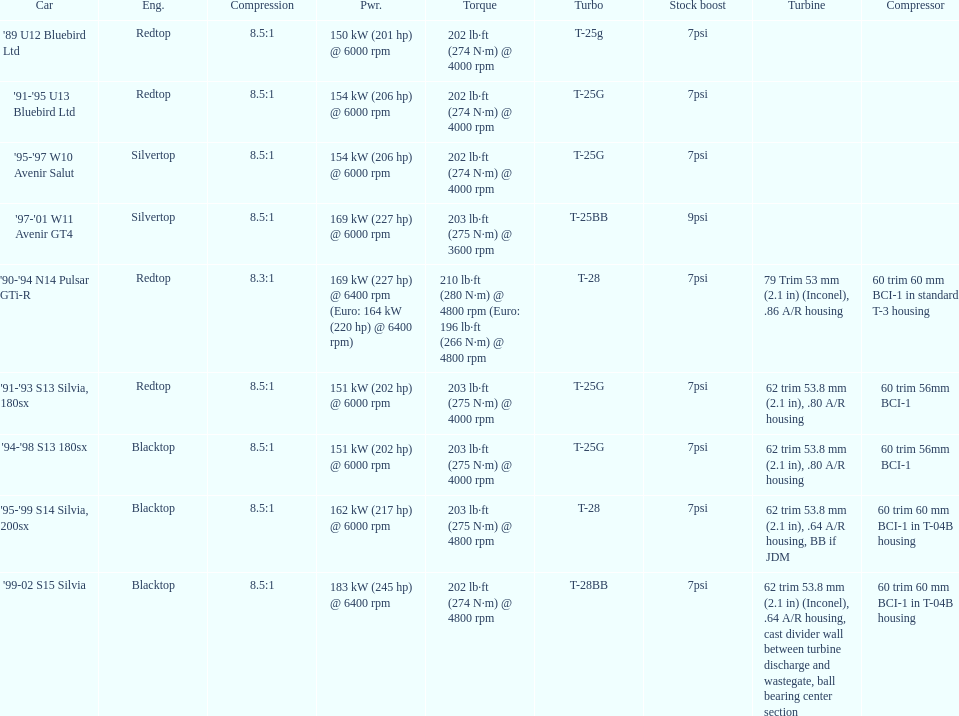Which car is the only one with more than 230 hp? '99-02 S15 Silvia. 